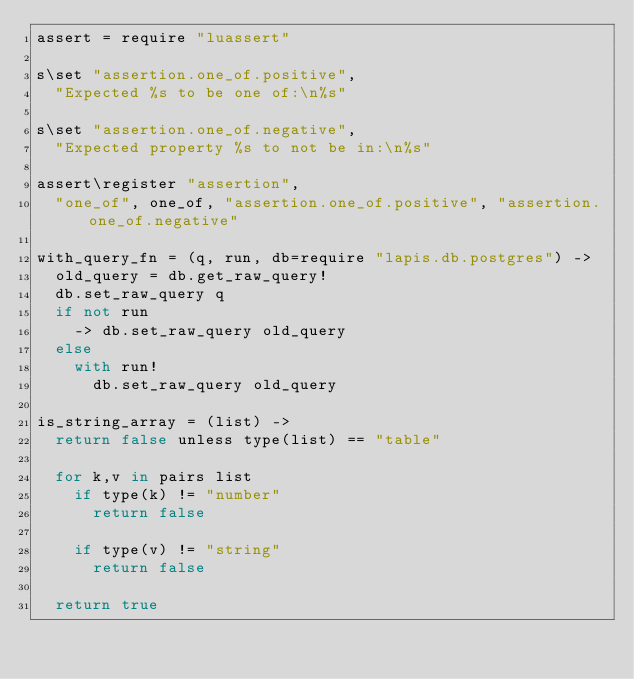<code> <loc_0><loc_0><loc_500><loc_500><_MoonScript_>assert = require "luassert"

s\set "assertion.one_of.positive",
  "Expected %s to be one of:\n%s"

s\set "assertion.one_of.negative",
  "Expected property %s to not be in:\n%s"

assert\register "assertion",
  "one_of", one_of, "assertion.one_of.positive", "assertion.one_of.negative"

with_query_fn = (q, run, db=require "lapis.db.postgres") ->
  old_query = db.get_raw_query!
  db.set_raw_query q
  if not run
    -> db.set_raw_query old_query
  else
    with run!
      db.set_raw_query old_query

is_string_array = (list) ->
  return false unless type(list) == "table"

  for k,v in pairs list
    if type(k) != "number"
      return false

    if type(v) != "string"
      return false

  return true
</code> 